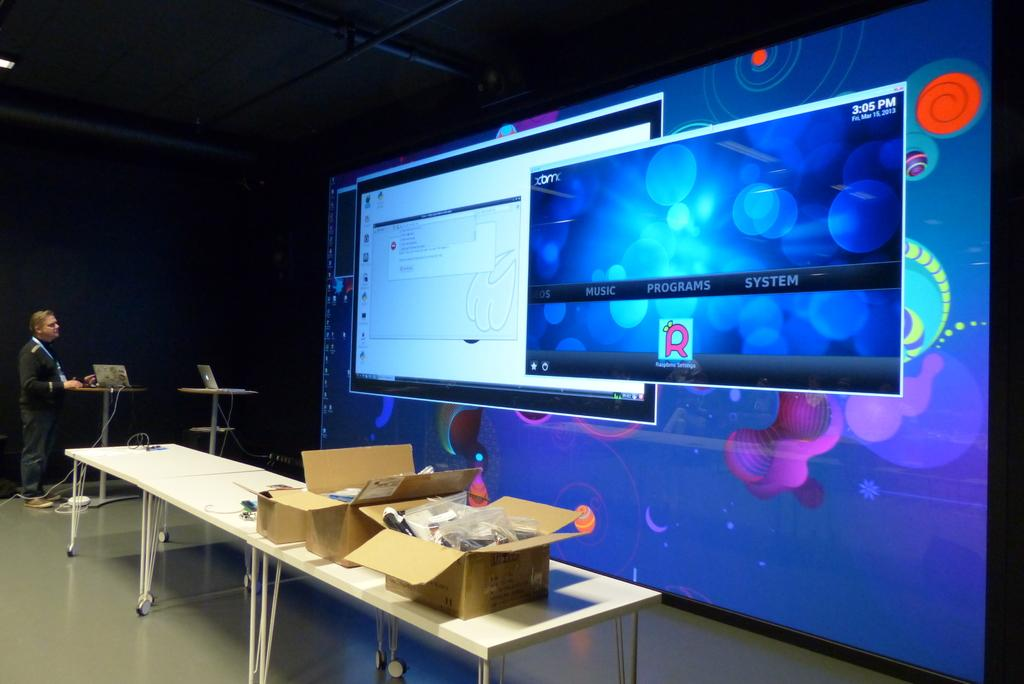<image>
Render a clear and concise summary of the photo. A large digital display shows a window with the options of music, programs and system on it. 